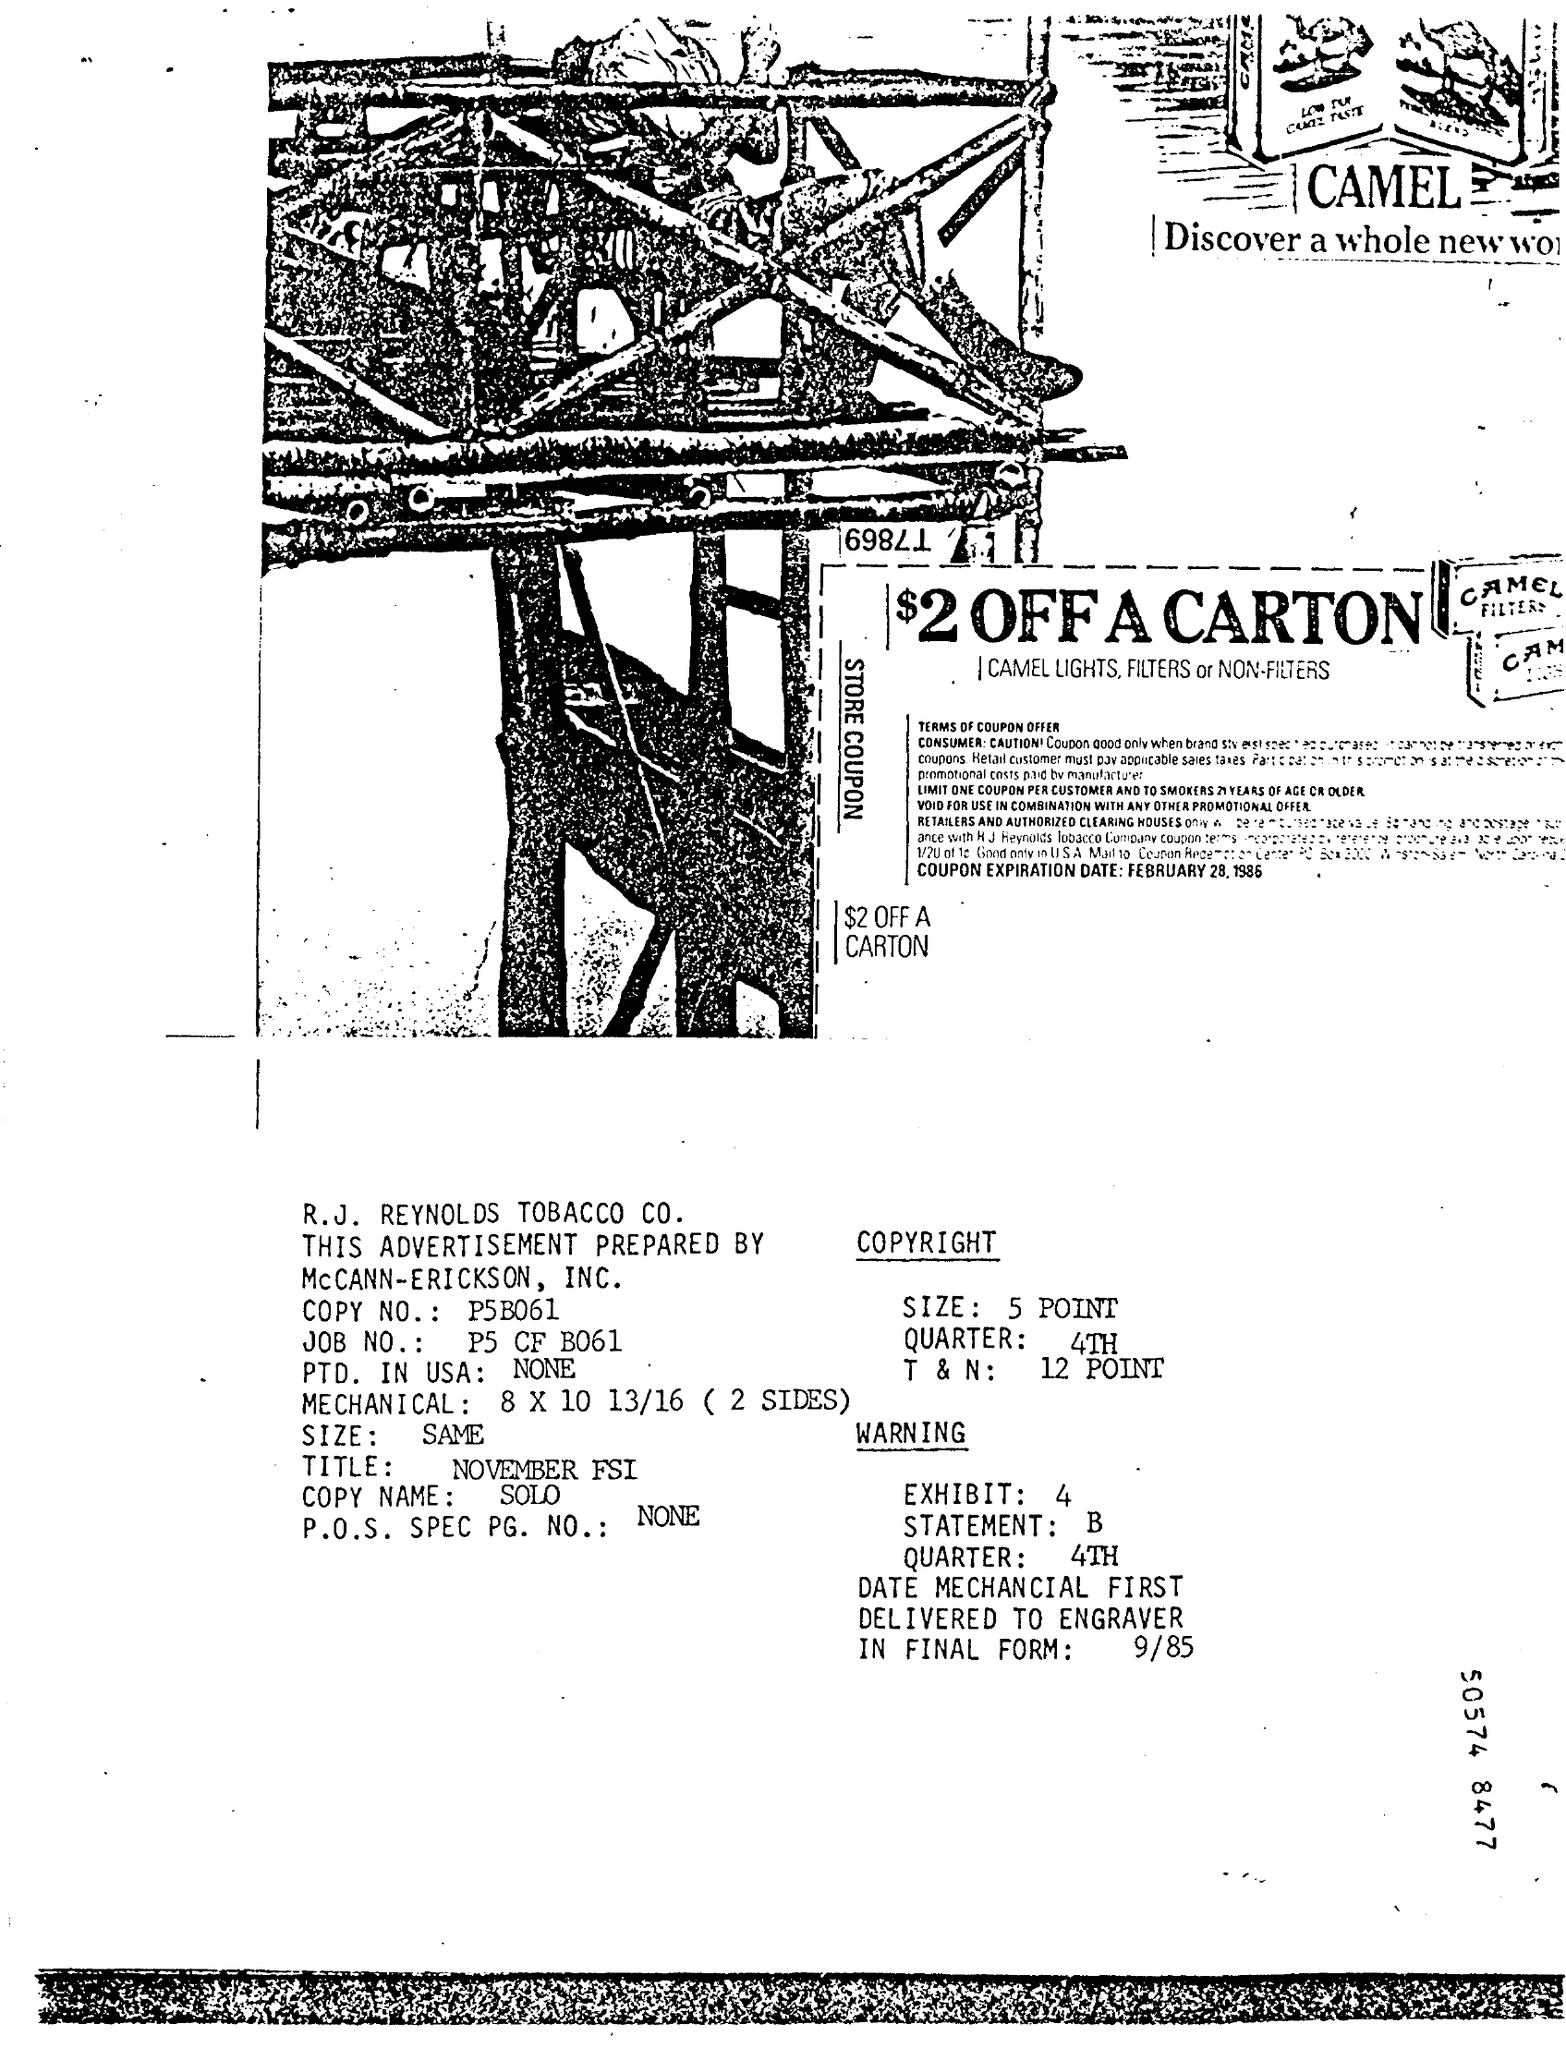What is the promotion on the store coupon?
Give a very brief answer. $2 OFF A CARTON. Which products are part of the promotion?
Provide a short and direct response. CAMEL LIGHTS, FILTERS or NON-FILTERS. Who has prepared the advertisement?
Ensure brevity in your answer.  McCANN-ERICKSON, INC. What is the COPY NO.?
Your answer should be compact. P5B061. 